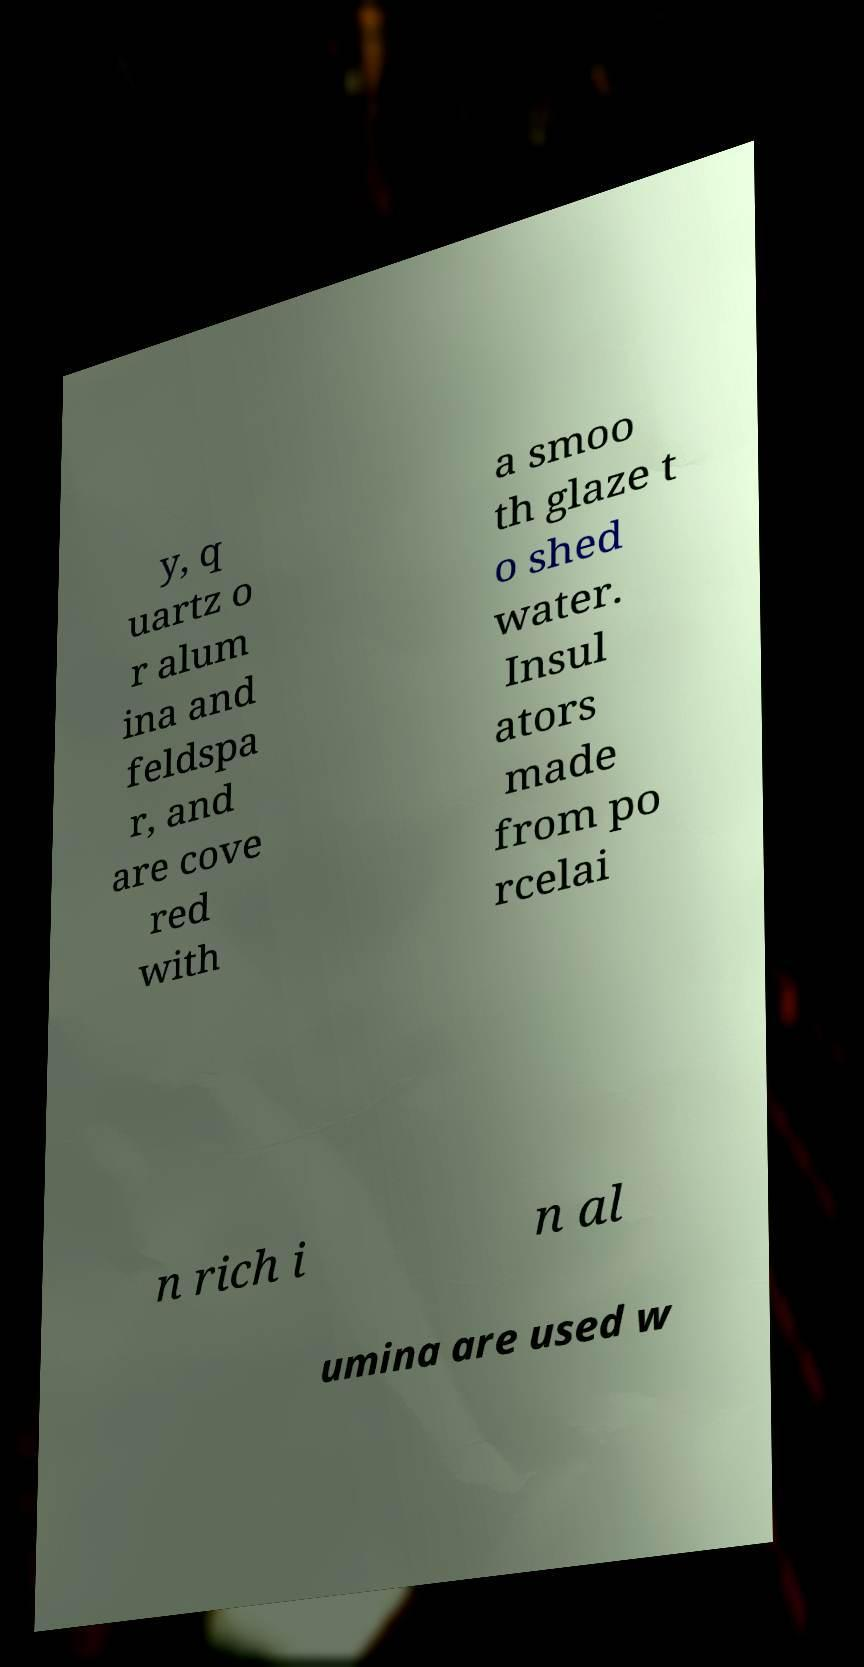Please read and relay the text visible in this image. What does it say? y, q uartz o r alum ina and feldspa r, and are cove red with a smoo th glaze t o shed water. Insul ators made from po rcelai n rich i n al umina are used w 